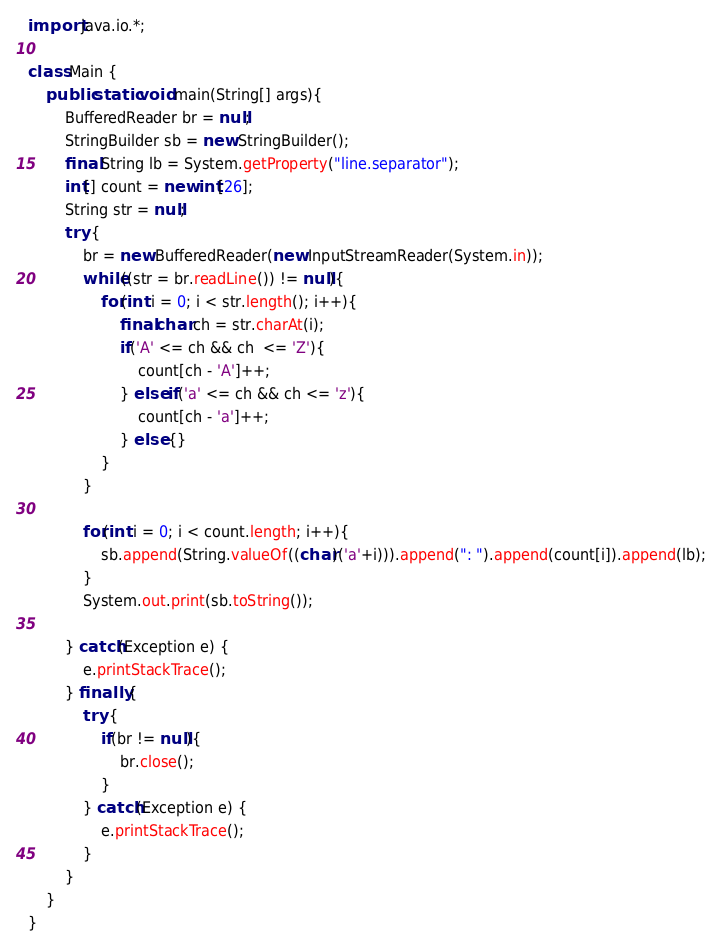Convert code to text. <code><loc_0><loc_0><loc_500><loc_500><_Java_>import java.io.*;

class Main {
	public static void main(String[] args){
		BufferedReader br = null;
		StringBuilder sb = new StringBuilder();
		final String lb = System.getProperty("line.separator");
		int[] count = new int[26];
		String str = null;
		try {
			br = new BufferedReader(new InputStreamReader(System.in));
			while((str = br.readLine()) != null){
				for(int i = 0; i < str.length(); i++){
					final char ch = str.charAt(i);
					if('A' <= ch && ch  <= 'Z'){
						count[ch - 'A']++;
					} else if('a' <= ch && ch <= 'z'){
						count[ch - 'a']++;
					} else {}
				}
			}

			for(int i = 0; i < count.length; i++){
				sb.append(String.valueOf((char)('a'+i))).append(": ").append(count[i]).append(lb);
			}
			System.out.print(sb.toString());

		} catch(Exception e) {
			e.printStackTrace();
		} finally {
			try {
				if(br != null){
					br.close();
				}
			} catch(Exception e) {
				e.printStackTrace();
			}
		}
	}
}</code> 